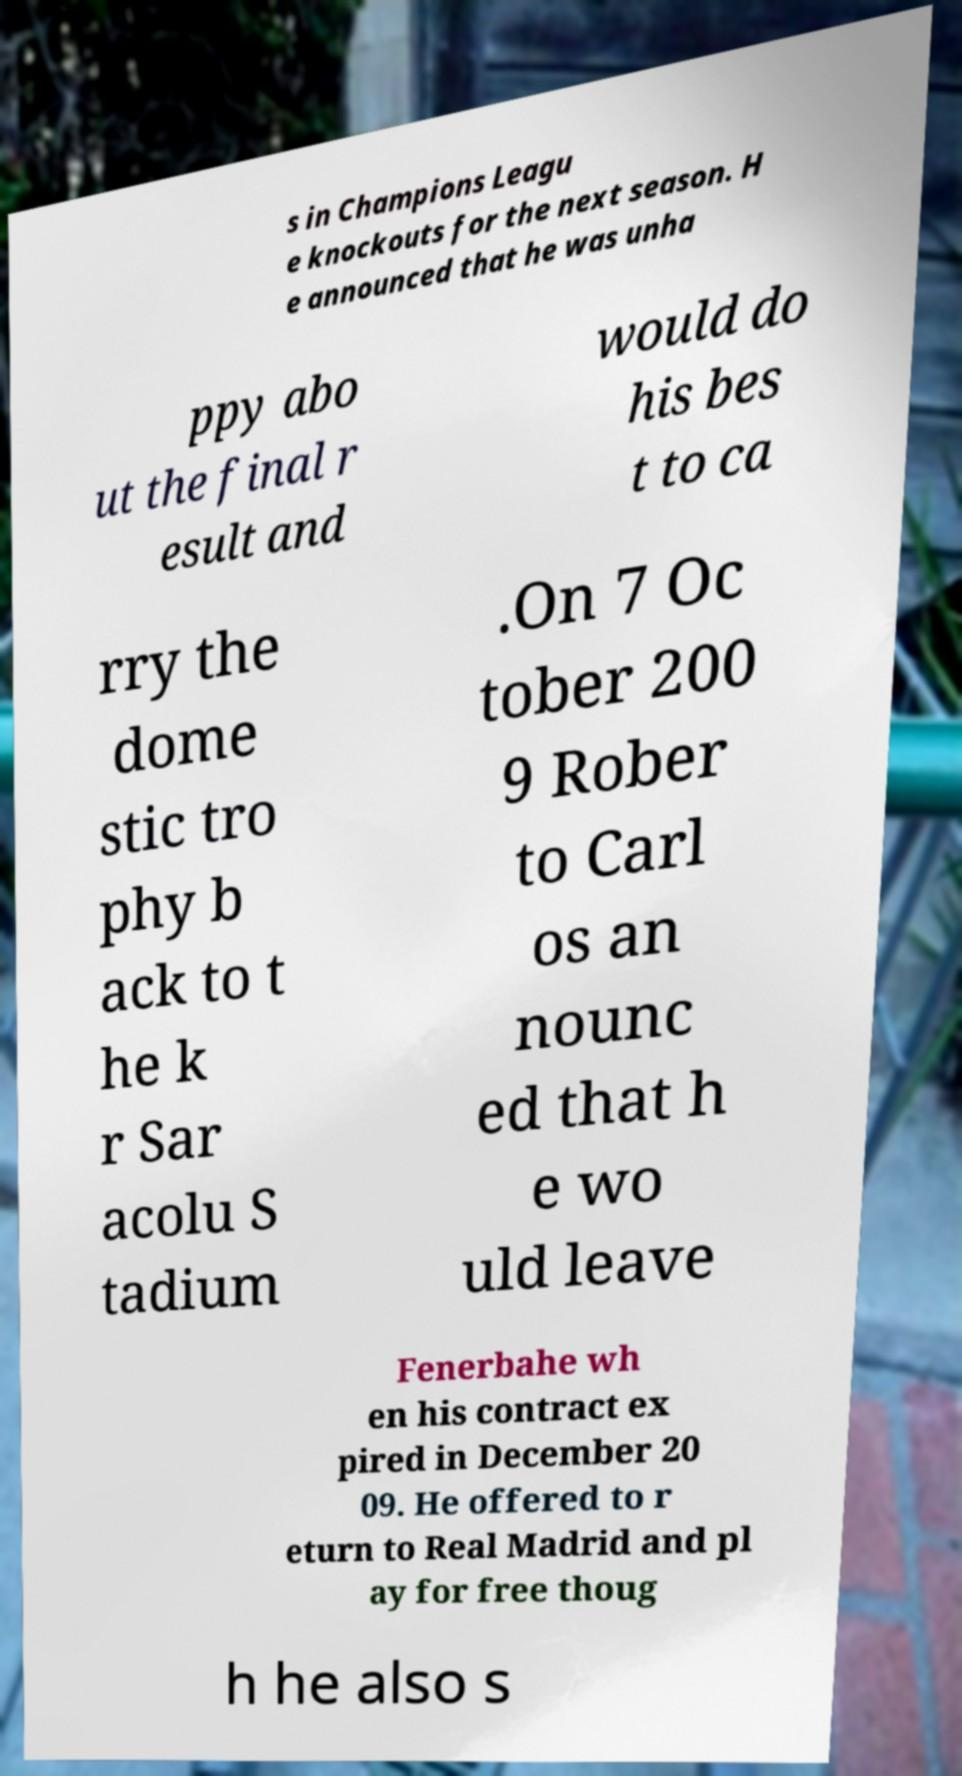Could you assist in decoding the text presented in this image and type it out clearly? s in Champions Leagu e knockouts for the next season. H e announced that he was unha ppy abo ut the final r esult and would do his bes t to ca rry the dome stic tro phy b ack to t he k r Sar acolu S tadium .On 7 Oc tober 200 9 Rober to Carl os an nounc ed that h e wo uld leave Fenerbahe wh en his contract ex pired in December 20 09. He offered to r eturn to Real Madrid and pl ay for free thoug h he also s 